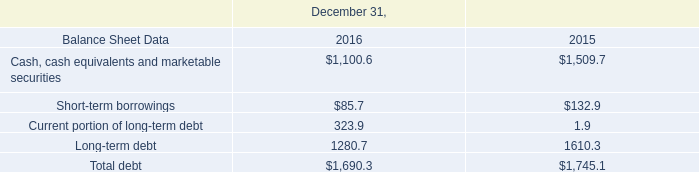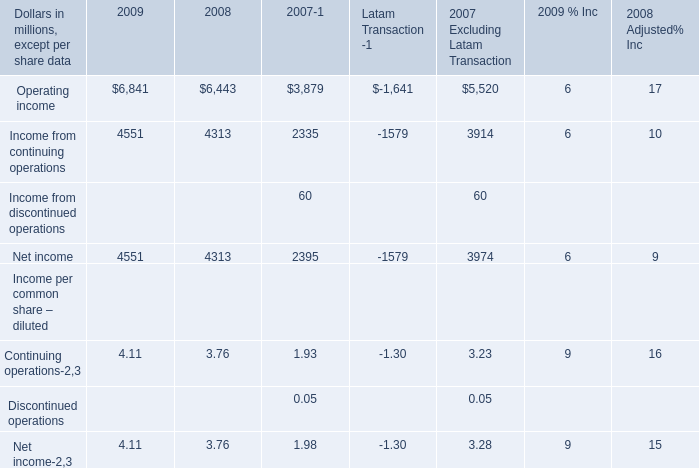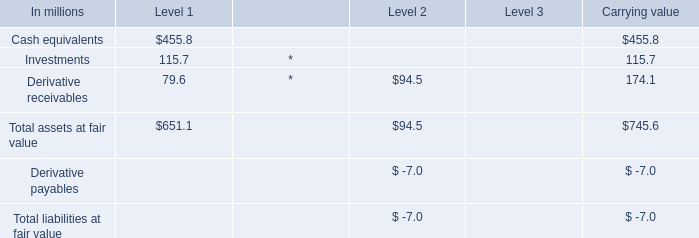If Operating income develops with the same increasing rate in 2009, what will it reach in 2010? (in million) 
Computations: (6841 * (1 + ((6841 - 6443) / 6443)))
Answer: 7263.58544. 